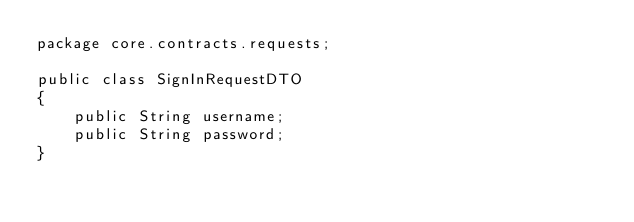Convert code to text. <code><loc_0><loc_0><loc_500><loc_500><_Java_>package core.contracts.requests;

public class SignInRequestDTO
{
    public String username;
    public String password;
}</code> 